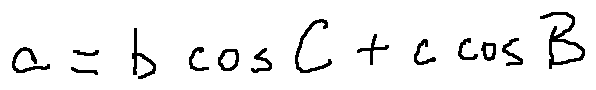Convert formula to latex. <formula><loc_0><loc_0><loc_500><loc_500>a = b \cos C + c \cos B</formula> 